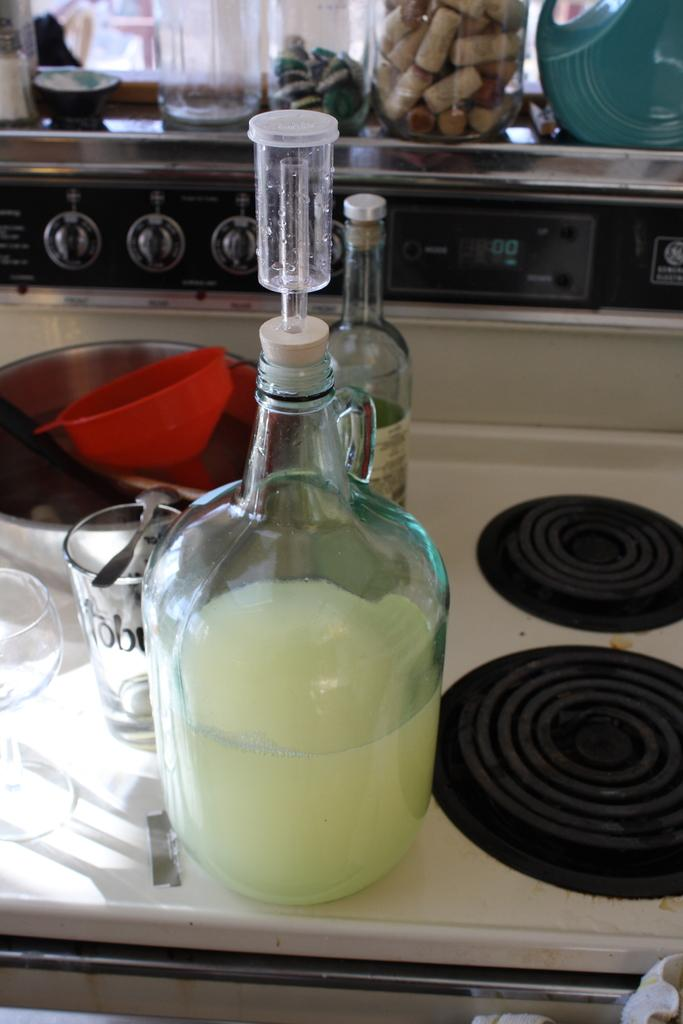How many bottles are visible in the image? There are two bottles in the image. What other objects can be seen in the image? There are two glasses and a spoon visible in the image. What can be seen in the background of the image? There is a stove and a few jars in the background of the image. What type of behavior is exhibited by the sofa in the image? There is no sofa present in the image, so it is not possible to determine any behavior. 